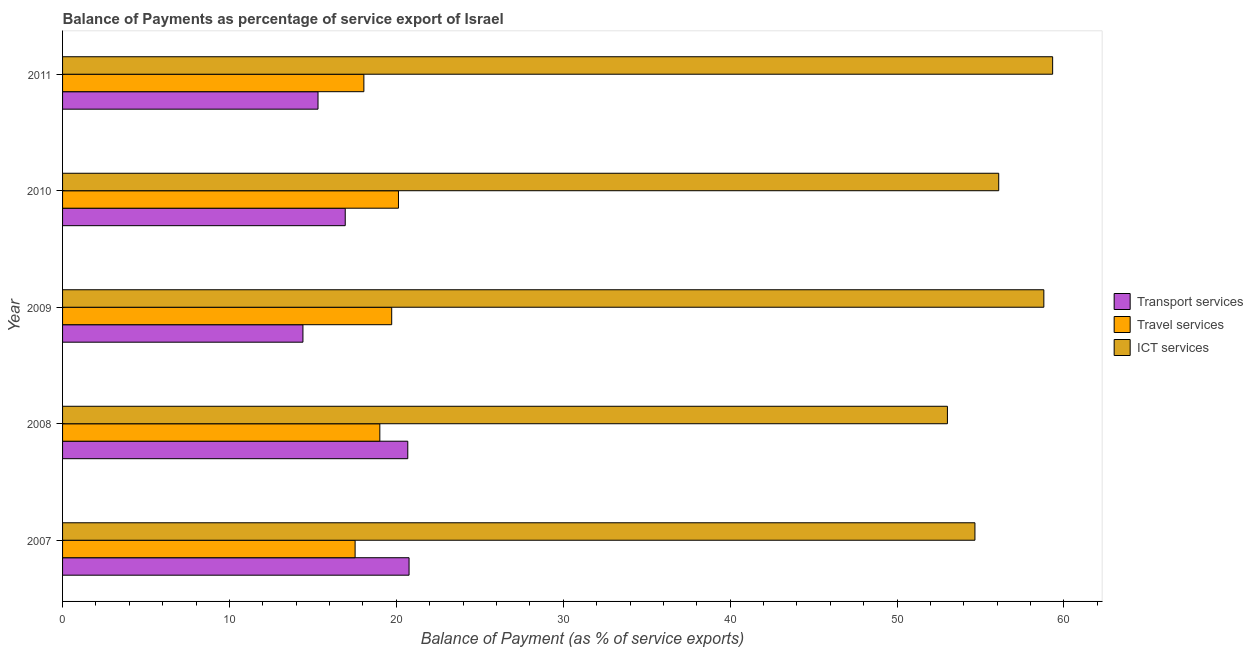How many different coloured bars are there?
Offer a very short reply. 3. How many groups of bars are there?
Your answer should be very brief. 5. Are the number of bars on each tick of the Y-axis equal?
Offer a very short reply. Yes. How many bars are there on the 4th tick from the top?
Provide a succinct answer. 3. How many bars are there on the 3rd tick from the bottom?
Provide a short and direct response. 3. What is the label of the 3rd group of bars from the top?
Ensure brevity in your answer.  2009. In how many cases, is the number of bars for a given year not equal to the number of legend labels?
Give a very brief answer. 0. What is the balance of payment of transport services in 2011?
Make the answer very short. 15.31. Across all years, what is the maximum balance of payment of ict services?
Provide a short and direct response. 59.32. Across all years, what is the minimum balance of payment of transport services?
Make the answer very short. 14.4. What is the total balance of payment of ict services in the graph?
Your answer should be very brief. 281.89. What is the difference between the balance of payment of transport services in 2008 and that in 2009?
Ensure brevity in your answer.  6.28. What is the difference between the balance of payment of travel services in 2010 and the balance of payment of transport services in 2008?
Your answer should be very brief. -0.56. What is the average balance of payment of transport services per year?
Offer a very short reply. 17.62. In the year 2008, what is the difference between the balance of payment of transport services and balance of payment of travel services?
Make the answer very short. 1.68. What is the ratio of the balance of payment of transport services in 2007 to that in 2011?
Your answer should be compact. 1.36. Is the balance of payment of ict services in 2009 less than that in 2010?
Offer a very short reply. No. What is the difference between the highest and the second highest balance of payment of transport services?
Keep it short and to the point. 0.08. In how many years, is the balance of payment of ict services greater than the average balance of payment of ict services taken over all years?
Provide a short and direct response. 2. What does the 3rd bar from the top in 2009 represents?
Your answer should be compact. Transport services. What does the 1st bar from the bottom in 2010 represents?
Provide a succinct answer. Transport services. Is it the case that in every year, the sum of the balance of payment of transport services and balance of payment of travel services is greater than the balance of payment of ict services?
Your answer should be very brief. No. Are all the bars in the graph horizontal?
Make the answer very short. Yes. How many years are there in the graph?
Your answer should be very brief. 5. Are the values on the major ticks of X-axis written in scientific E-notation?
Offer a very short reply. No. Where does the legend appear in the graph?
Make the answer very short. Center right. How many legend labels are there?
Your answer should be compact. 3. What is the title of the graph?
Offer a very short reply. Balance of Payments as percentage of service export of Israel. What is the label or title of the X-axis?
Ensure brevity in your answer.  Balance of Payment (as % of service exports). What is the label or title of the Y-axis?
Make the answer very short. Year. What is the Balance of Payment (as % of service exports) of Transport services in 2007?
Your answer should be compact. 20.76. What is the Balance of Payment (as % of service exports) in Travel services in 2007?
Provide a short and direct response. 17.53. What is the Balance of Payment (as % of service exports) of ICT services in 2007?
Your response must be concise. 54.67. What is the Balance of Payment (as % of service exports) in Transport services in 2008?
Give a very brief answer. 20.68. What is the Balance of Payment (as % of service exports) in Travel services in 2008?
Offer a very short reply. 19.01. What is the Balance of Payment (as % of service exports) in ICT services in 2008?
Provide a succinct answer. 53.02. What is the Balance of Payment (as % of service exports) in Transport services in 2009?
Your answer should be compact. 14.4. What is the Balance of Payment (as % of service exports) in Travel services in 2009?
Your answer should be very brief. 19.72. What is the Balance of Payment (as % of service exports) in ICT services in 2009?
Make the answer very short. 58.8. What is the Balance of Payment (as % of service exports) in Transport services in 2010?
Your answer should be compact. 16.94. What is the Balance of Payment (as % of service exports) of Travel services in 2010?
Ensure brevity in your answer.  20.13. What is the Balance of Payment (as % of service exports) in ICT services in 2010?
Offer a very short reply. 56.09. What is the Balance of Payment (as % of service exports) of Transport services in 2011?
Ensure brevity in your answer.  15.31. What is the Balance of Payment (as % of service exports) in Travel services in 2011?
Provide a succinct answer. 18.05. What is the Balance of Payment (as % of service exports) in ICT services in 2011?
Provide a short and direct response. 59.32. Across all years, what is the maximum Balance of Payment (as % of service exports) in Transport services?
Your answer should be compact. 20.76. Across all years, what is the maximum Balance of Payment (as % of service exports) in Travel services?
Your answer should be compact. 20.13. Across all years, what is the maximum Balance of Payment (as % of service exports) in ICT services?
Your response must be concise. 59.32. Across all years, what is the minimum Balance of Payment (as % of service exports) in Transport services?
Ensure brevity in your answer.  14.4. Across all years, what is the minimum Balance of Payment (as % of service exports) in Travel services?
Give a very brief answer. 17.53. Across all years, what is the minimum Balance of Payment (as % of service exports) of ICT services?
Ensure brevity in your answer.  53.02. What is the total Balance of Payment (as % of service exports) in Transport services in the graph?
Give a very brief answer. 88.09. What is the total Balance of Payment (as % of service exports) in Travel services in the graph?
Provide a short and direct response. 94.44. What is the total Balance of Payment (as % of service exports) in ICT services in the graph?
Ensure brevity in your answer.  281.89. What is the difference between the Balance of Payment (as % of service exports) of Transport services in 2007 and that in 2008?
Keep it short and to the point. 0.08. What is the difference between the Balance of Payment (as % of service exports) in Travel services in 2007 and that in 2008?
Provide a succinct answer. -1.48. What is the difference between the Balance of Payment (as % of service exports) in ICT services in 2007 and that in 2008?
Your response must be concise. 1.65. What is the difference between the Balance of Payment (as % of service exports) in Transport services in 2007 and that in 2009?
Your answer should be compact. 6.36. What is the difference between the Balance of Payment (as % of service exports) of Travel services in 2007 and that in 2009?
Offer a terse response. -2.19. What is the difference between the Balance of Payment (as % of service exports) in ICT services in 2007 and that in 2009?
Your response must be concise. -4.13. What is the difference between the Balance of Payment (as % of service exports) in Transport services in 2007 and that in 2010?
Provide a short and direct response. 3.82. What is the difference between the Balance of Payment (as % of service exports) of Travel services in 2007 and that in 2010?
Keep it short and to the point. -2.6. What is the difference between the Balance of Payment (as % of service exports) of ICT services in 2007 and that in 2010?
Make the answer very short. -1.42. What is the difference between the Balance of Payment (as % of service exports) in Transport services in 2007 and that in 2011?
Provide a short and direct response. 5.45. What is the difference between the Balance of Payment (as % of service exports) of Travel services in 2007 and that in 2011?
Make the answer very short. -0.52. What is the difference between the Balance of Payment (as % of service exports) of ICT services in 2007 and that in 2011?
Provide a succinct answer. -4.66. What is the difference between the Balance of Payment (as % of service exports) in Transport services in 2008 and that in 2009?
Make the answer very short. 6.28. What is the difference between the Balance of Payment (as % of service exports) of Travel services in 2008 and that in 2009?
Offer a terse response. -0.71. What is the difference between the Balance of Payment (as % of service exports) of ICT services in 2008 and that in 2009?
Ensure brevity in your answer.  -5.78. What is the difference between the Balance of Payment (as % of service exports) of Transport services in 2008 and that in 2010?
Give a very brief answer. 3.75. What is the difference between the Balance of Payment (as % of service exports) of Travel services in 2008 and that in 2010?
Offer a terse response. -1.12. What is the difference between the Balance of Payment (as % of service exports) of ICT services in 2008 and that in 2010?
Ensure brevity in your answer.  -3.07. What is the difference between the Balance of Payment (as % of service exports) in Transport services in 2008 and that in 2011?
Make the answer very short. 5.38. What is the difference between the Balance of Payment (as % of service exports) in Travel services in 2008 and that in 2011?
Make the answer very short. 0.96. What is the difference between the Balance of Payment (as % of service exports) of ICT services in 2008 and that in 2011?
Your answer should be compact. -6.3. What is the difference between the Balance of Payment (as % of service exports) of Transport services in 2009 and that in 2010?
Your answer should be very brief. -2.53. What is the difference between the Balance of Payment (as % of service exports) of Travel services in 2009 and that in 2010?
Your response must be concise. -0.41. What is the difference between the Balance of Payment (as % of service exports) of ICT services in 2009 and that in 2010?
Give a very brief answer. 2.7. What is the difference between the Balance of Payment (as % of service exports) in Transport services in 2009 and that in 2011?
Provide a succinct answer. -0.9. What is the difference between the Balance of Payment (as % of service exports) of Travel services in 2009 and that in 2011?
Give a very brief answer. 1.67. What is the difference between the Balance of Payment (as % of service exports) of ICT services in 2009 and that in 2011?
Your answer should be very brief. -0.53. What is the difference between the Balance of Payment (as % of service exports) in Transport services in 2010 and that in 2011?
Your response must be concise. 1.63. What is the difference between the Balance of Payment (as % of service exports) of Travel services in 2010 and that in 2011?
Give a very brief answer. 2.07. What is the difference between the Balance of Payment (as % of service exports) in ICT services in 2010 and that in 2011?
Offer a very short reply. -3.23. What is the difference between the Balance of Payment (as % of service exports) in Transport services in 2007 and the Balance of Payment (as % of service exports) in Travel services in 2008?
Keep it short and to the point. 1.75. What is the difference between the Balance of Payment (as % of service exports) in Transport services in 2007 and the Balance of Payment (as % of service exports) in ICT services in 2008?
Provide a short and direct response. -32.26. What is the difference between the Balance of Payment (as % of service exports) of Travel services in 2007 and the Balance of Payment (as % of service exports) of ICT services in 2008?
Your response must be concise. -35.49. What is the difference between the Balance of Payment (as % of service exports) in Transport services in 2007 and the Balance of Payment (as % of service exports) in Travel services in 2009?
Provide a succinct answer. 1.04. What is the difference between the Balance of Payment (as % of service exports) in Transport services in 2007 and the Balance of Payment (as % of service exports) in ICT services in 2009?
Your response must be concise. -38.03. What is the difference between the Balance of Payment (as % of service exports) of Travel services in 2007 and the Balance of Payment (as % of service exports) of ICT services in 2009?
Offer a terse response. -41.27. What is the difference between the Balance of Payment (as % of service exports) in Transport services in 2007 and the Balance of Payment (as % of service exports) in Travel services in 2010?
Your answer should be very brief. 0.63. What is the difference between the Balance of Payment (as % of service exports) of Transport services in 2007 and the Balance of Payment (as % of service exports) of ICT services in 2010?
Your response must be concise. -35.33. What is the difference between the Balance of Payment (as % of service exports) in Travel services in 2007 and the Balance of Payment (as % of service exports) in ICT services in 2010?
Provide a succinct answer. -38.56. What is the difference between the Balance of Payment (as % of service exports) in Transport services in 2007 and the Balance of Payment (as % of service exports) in Travel services in 2011?
Your answer should be very brief. 2.71. What is the difference between the Balance of Payment (as % of service exports) of Transport services in 2007 and the Balance of Payment (as % of service exports) of ICT services in 2011?
Provide a succinct answer. -38.56. What is the difference between the Balance of Payment (as % of service exports) of Travel services in 2007 and the Balance of Payment (as % of service exports) of ICT services in 2011?
Offer a terse response. -41.79. What is the difference between the Balance of Payment (as % of service exports) of Transport services in 2008 and the Balance of Payment (as % of service exports) of Travel services in 2009?
Offer a very short reply. 0.96. What is the difference between the Balance of Payment (as % of service exports) of Transport services in 2008 and the Balance of Payment (as % of service exports) of ICT services in 2009?
Your response must be concise. -38.11. What is the difference between the Balance of Payment (as % of service exports) in Travel services in 2008 and the Balance of Payment (as % of service exports) in ICT services in 2009?
Offer a very short reply. -39.79. What is the difference between the Balance of Payment (as % of service exports) of Transport services in 2008 and the Balance of Payment (as % of service exports) of Travel services in 2010?
Provide a succinct answer. 0.56. What is the difference between the Balance of Payment (as % of service exports) in Transport services in 2008 and the Balance of Payment (as % of service exports) in ICT services in 2010?
Keep it short and to the point. -35.41. What is the difference between the Balance of Payment (as % of service exports) of Travel services in 2008 and the Balance of Payment (as % of service exports) of ICT services in 2010?
Provide a short and direct response. -37.08. What is the difference between the Balance of Payment (as % of service exports) in Transport services in 2008 and the Balance of Payment (as % of service exports) in Travel services in 2011?
Your answer should be compact. 2.63. What is the difference between the Balance of Payment (as % of service exports) of Transport services in 2008 and the Balance of Payment (as % of service exports) of ICT services in 2011?
Your answer should be very brief. -38.64. What is the difference between the Balance of Payment (as % of service exports) of Travel services in 2008 and the Balance of Payment (as % of service exports) of ICT services in 2011?
Offer a very short reply. -40.31. What is the difference between the Balance of Payment (as % of service exports) in Transport services in 2009 and the Balance of Payment (as % of service exports) in Travel services in 2010?
Your answer should be very brief. -5.72. What is the difference between the Balance of Payment (as % of service exports) in Transport services in 2009 and the Balance of Payment (as % of service exports) in ICT services in 2010?
Provide a succinct answer. -41.69. What is the difference between the Balance of Payment (as % of service exports) in Travel services in 2009 and the Balance of Payment (as % of service exports) in ICT services in 2010?
Give a very brief answer. -36.37. What is the difference between the Balance of Payment (as % of service exports) in Transport services in 2009 and the Balance of Payment (as % of service exports) in Travel services in 2011?
Your answer should be compact. -3.65. What is the difference between the Balance of Payment (as % of service exports) in Transport services in 2009 and the Balance of Payment (as % of service exports) in ICT services in 2011?
Keep it short and to the point. -44.92. What is the difference between the Balance of Payment (as % of service exports) in Travel services in 2009 and the Balance of Payment (as % of service exports) in ICT services in 2011?
Ensure brevity in your answer.  -39.6. What is the difference between the Balance of Payment (as % of service exports) of Transport services in 2010 and the Balance of Payment (as % of service exports) of Travel services in 2011?
Ensure brevity in your answer.  -1.12. What is the difference between the Balance of Payment (as % of service exports) in Transport services in 2010 and the Balance of Payment (as % of service exports) in ICT services in 2011?
Keep it short and to the point. -42.39. What is the difference between the Balance of Payment (as % of service exports) in Travel services in 2010 and the Balance of Payment (as % of service exports) in ICT services in 2011?
Offer a very short reply. -39.2. What is the average Balance of Payment (as % of service exports) of Transport services per year?
Offer a very short reply. 17.62. What is the average Balance of Payment (as % of service exports) of Travel services per year?
Provide a short and direct response. 18.89. What is the average Balance of Payment (as % of service exports) in ICT services per year?
Offer a very short reply. 56.38. In the year 2007, what is the difference between the Balance of Payment (as % of service exports) in Transport services and Balance of Payment (as % of service exports) in Travel services?
Provide a succinct answer. 3.23. In the year 2007, what is the difference between the Balance of Payment (as % of service exports) of Transport services and Balance of Payment (as % of service exports) of ICT services?
Your response must be concise. -33.91. In the year 2007, what is the difference between the Balance of Payment (as % of service exports) in Travel services and Balance of Payment (as % of service exports) in ICT services?
Provide a short and direct response. -37.14. In the year 2008, what is the difference between the Balance of Payment (as % of service exports) in Transport services and Balance of Payment (as % of service exports) in Travel services?
Your answer should be compact. 1.68. In the year 2008, what is the difference between the Balance of Payment (as % of service exports) of Transport services and Balance of Payment (as % of service exports) of ICT services?
Provide a succinct answer. -32.33. In the year 2008, what is the difference between the Balance of Payment (as % of service exports) of Travel services and Balance of Payment (as % of service exports) of ICT services?
Make the answer very short. -34.01. In the year 2009, what is the difference between the Balance of Payment (as % of service exports) of Transport services and Balance of Payment (as % of service exports) of Travel services?
Give a very brief answer. -5.32. In the year 2009, what is the difference between the Balance of Payment (as % of service exports) of Transport services and Balance of Payment (as % of service exports) of ICT services?
Make the answer very short. -44.39. In the year 2009, what is the difference between the Balance of Payment (as % of service exports) in Travel services and Balance of Payment (as % of service exports) in ICT services?
Keep it short and to the point. -39.07. In the year 2010, what is the difference between the Balance of Payment (as % of service exports) of Transport services and Balance of Payment (as % of service exports) of Travel services?
Provide a short and direct response. -3.19. In the year 2010, what is the difference between the Balance of Payment (as % of service exports) of Transport services and Balance of Payment (as % of service exports) of ICT services?
Offer a very short reply. -39.15. In the year 2010, what is the difference between the Balance of Payment (as % of service exports) in Travel services and Balance of Payment (as % of service exports) in ICT services?
Keep it short and to the point. -35.97. In the year 2011, what is the difference between the Balance of Payment (as % of service exports) of Transport services and Balance of Payment (as % of service exports) of Travel services?
Offer a terse response. -2.75. In the year 2011, what is the difference between the Balance of Payment (as % of service exports) of Transport services and Balance of Payment (as % of service exports) of ICT services?
Your answer should be very brief. -44.02. In the year 2011, what is the difference between the Balance of Payment (as % of service exports) in Travel services and Balance of Payment (as % of service exports) in ICT services?
Ensure brevity in your answer.  -41.27. What is the ratio of the Balance of Payment (as % of service exports) of Transport services in 2007 to that in 2008?
Make the answer very short. 1. What is the ratio of the Balance of Payment (as % of service exports) in Travel services in 2007 to that in 2008?
Provide a short and direct response. 0.92. What is the ratio of the Balance of Payment (as % of service exports) in ICT services in 2007 to that in 2008?
Make the answer very short. 1.03. What is the ratio of the Balance of Payment (as % of service exports) of Transport services in 2007 to that in 2009?
Offer a very short reply. 1.44. What is the ratio of the Balance of Payment (as % of service exports) in Travel services in 2007 to that in 2009?
Make the answer very short. 0.89. What is the ratio of the Balance of Payment (as % of service exports) in ICT services in 2007 to that in 2009?
Provide a short and direct response. 0.93. What is the ratio of the Balance of Payment (as % of service exports) of Transport services in 2007 to that in 2010?
Give a very brief answer. 1.23. What is the ratio of the Balance of Payment (as % of service exports) of Travel services in 2007 to that in 2010?
Offer a terse response. 0.87. What is the ratio of the Balance of Payment (as % of service exports) in ICT services in 2007 to that in 2010?
Provide a succinct answer. 0.97. What is the ratio of the Balance of Payment (as % of service exports) of Transport services in 2007 to that in 2011?
Offer a very short reply. 1.36. What is the ratio of the Balance of Payment (as % of service exports) in Travel services in 2007 to that in 2011?
Your answer should be very brief. 0.97. What is the ratio of the Balance of Payment (as % of service exports) of ICT services in 2007 to that in 2011?
Provide a succinct answer. 0.92. What is the ratio of the Balance of Payment (as % of service exports) in Transport services in 2008 to that in 2009?
Make the answer very short. 1.44. What is the ratio of the Balance of Payment (as % of service exports) of Travel services in 2008 to that in 2009?
Offer a very short reply. 0.96. What is the ratio of the Balance of Payment (as % of service exports) of ICT services in 2008 to that in 2009?
Your answer should be very brief. 0.9. What is the ratio of the Balance of Payment (as % of service exports) of Transport services in 2008 to that in 2010?
Offer a very short reply. 1.22. What is the ratio of the Balance of Payment (as % of service exports) in Travel services in 2008 to that in 2010?
Ensure brevity in your answer.  0.94. What is the ratio of the Balance of Payment (as % of service exports) of ICT services in 2008 to that in 2010?
Keep it short and to the point. 0.95. What is the ratio of the Balance of Payment (as % of service exports) in Transport services in 2008 to that in 2011?
Offer a terse response. 1.35. What is the ratio of the Balance of Payment (as % of service exports) in Travel services in 2008 to that in 2011?
Make the answer very short. 1.05. What is the ratio of the Balance of Payment (as % of service exports) in ICT services in 2008 to that in 2011?
Give a very brief answer. 0.89. What is the ratio of the Balance of Payment (as % of service exports) in Transport services in 2009 to that in 2010?
Provide a short and direct response. 0.85. What is the ratio of the Balance of Payment (as % of service exports) of Travel services in 2009 to that in 2010?
Provide a succinct answer. 0.98. What is the ratio of the Balance of Payment (as % of service exports) of ICT services in 2009 to that in 2010?
Offer a terse response. 1.05. What is the ratio of the Balance of Payment (as % of service exports) of Transport services in 2009 to that in 2011?
Your response must be concise. 0.94. What is the ratio of the Balance of Payment (as % of service exports) in Travel services in 2009 to that in 2011?
Your answer should be compact. 1.09. What is the ratio of the Balance of Payment (as % of service exports) in Transport services in 2010 to that in 2011?
Offer a very short reply. 1.11. What is the ratio of the Balance of Payment (as % of service exports) of Travel services in 2010 to that in 2011?
Your response must be concise. 1.11. What is the ratio of the Balance of Payment (as % of service exports) of ICT services in 2010 to that in 2011?
Provide a succinct answer. 0.95. What is the difference between the highest and the second highest Balance of Payment (as % of service exports) in Transport services?
Ensure brevity in your answer.  0.08. What is the difference between the highest and the second highest Balance of Payment (as % of service exports) in Travel services?
Provide a succinct answer. 0.41. What is the difference between the highest and the second highest Balance of Payment (as % of service exports) in ICT services?
Provide a succinct answer. 0.53. What is the difference between the highest and the lowest Balance of Payment (as % of service exports) in Transport services?
Make the answer very short. 6.36. What is the difference between the highest and the lowest Balance of Payment (as % of service exports) of Travel services?
Your response must be concise. 2.6. What is the difference between the highest and the lowest Balance of Payment (as % of service exports) in ICT services?
Your answer should be very brief. 6.3. 